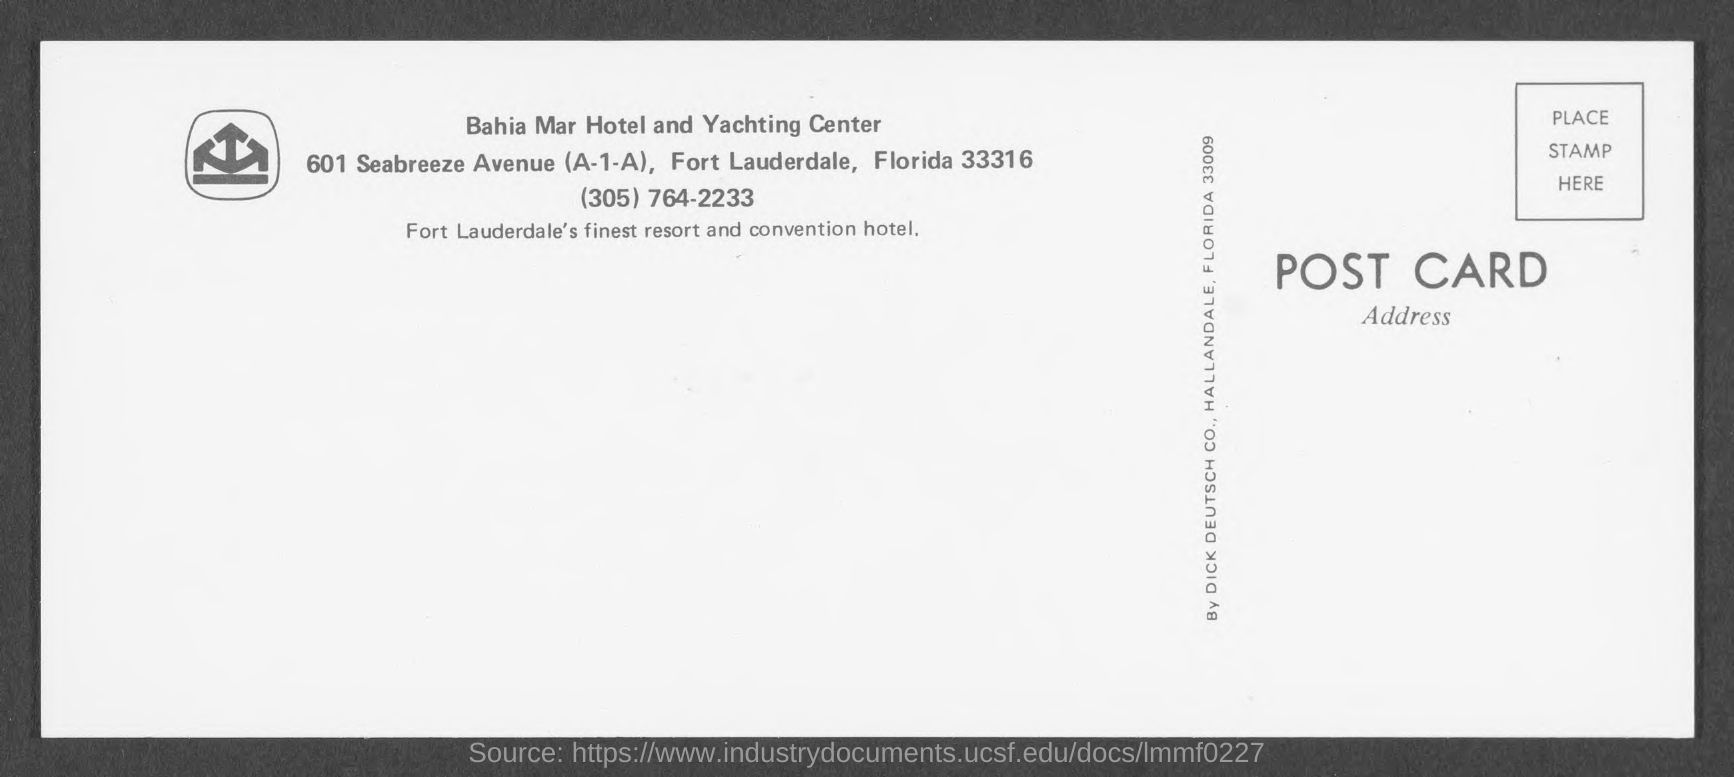Identify some key points in this picture. The Zip code of Fort Lauderdale is 33316. 